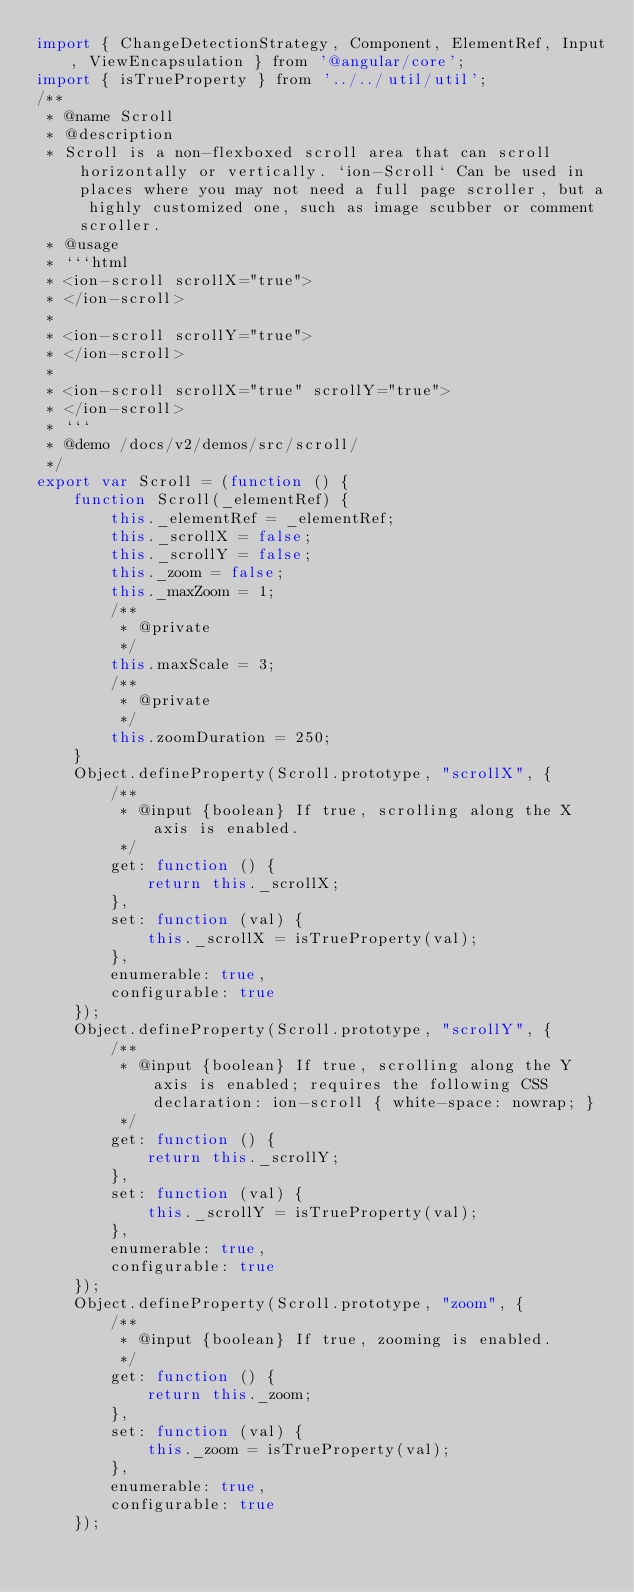Convert code to text. <code><loc_0><loc_0><loc_500><loc_500><_JavaScript_>import { ChangeDetectionStrategy, Component, ElementRef, Input, ViewEncapsulation } from '@angular/core';
import { isTrueProperty } from '../../util/util';
/**
 * @name Scroll
 * @description
 * Scroll is a non-flexboxed scroll area that can scroll horizontally or vertically. `ion-Scroll` Can be used in places where you may not need a full page scroller, but a highly customized one, such as image scubber or comment scroller.
 * @usage
 * ```html
 * <ion-scroll scrollX="true">
 * </ion-scroll>
 *
 * <ion-scroll scrollY="true">
 * </ion-scroll>
 *
 * <ion-scroll scrollX="true" scrollY="true">
 * </ion-scroll>
 * ```
 * @demo /docs/v2/demos/src/scroll/
 */
export var Scroll = (function () {
    function Scroll(_elementRef) {
        this._elementRef = _elementRef;
        this._scrollX = false;
        this._scrollY = false;
        this._zoom = false;
        this._maxZoom = 1;
        /**
         * @private
         */
        this.maxScale = 3;
        /**
         * @private
         */
        this.zoomDuration = 250;
    }
    Object.defineProperty(Scroll.prototype, "scrollX", {
        /**
         * @input {boolean} If true, scrolling along the X axis is enabled.
         */
        get: function () {
            return this._scrollX;
        },
        set: function (val) {
            this._scrollX = isTrueProperty(val);
        },
        enumerable: true,
        configurable: true
    });
    Object.defineProperty(Scroll.prototype, "scrollY", {
        /**
         * @input {boolean} If true, scrolling along the Y axis is enabled; requires the following CSS declaration: ion-scroll { white-space: nowrap; }
         */
        get: function () {
            return this._scrollY;
        },
        set: function (val) {
            this._scrollY = isTrueProperty(val);
        },
        enumerable: true,
        configurable: true
    });
    Object.defineProperty(Scroll.prototype, "zoom", {
        /**
         * @input {boolean} If true, zooming is enabled.
         */
        get: function () {
            return this._zoom;
        },
        set: function (val) {
            this._zoom = isTrueProperty(val);
        },
        enumerable: true,
        configurable: true
    });</code> 